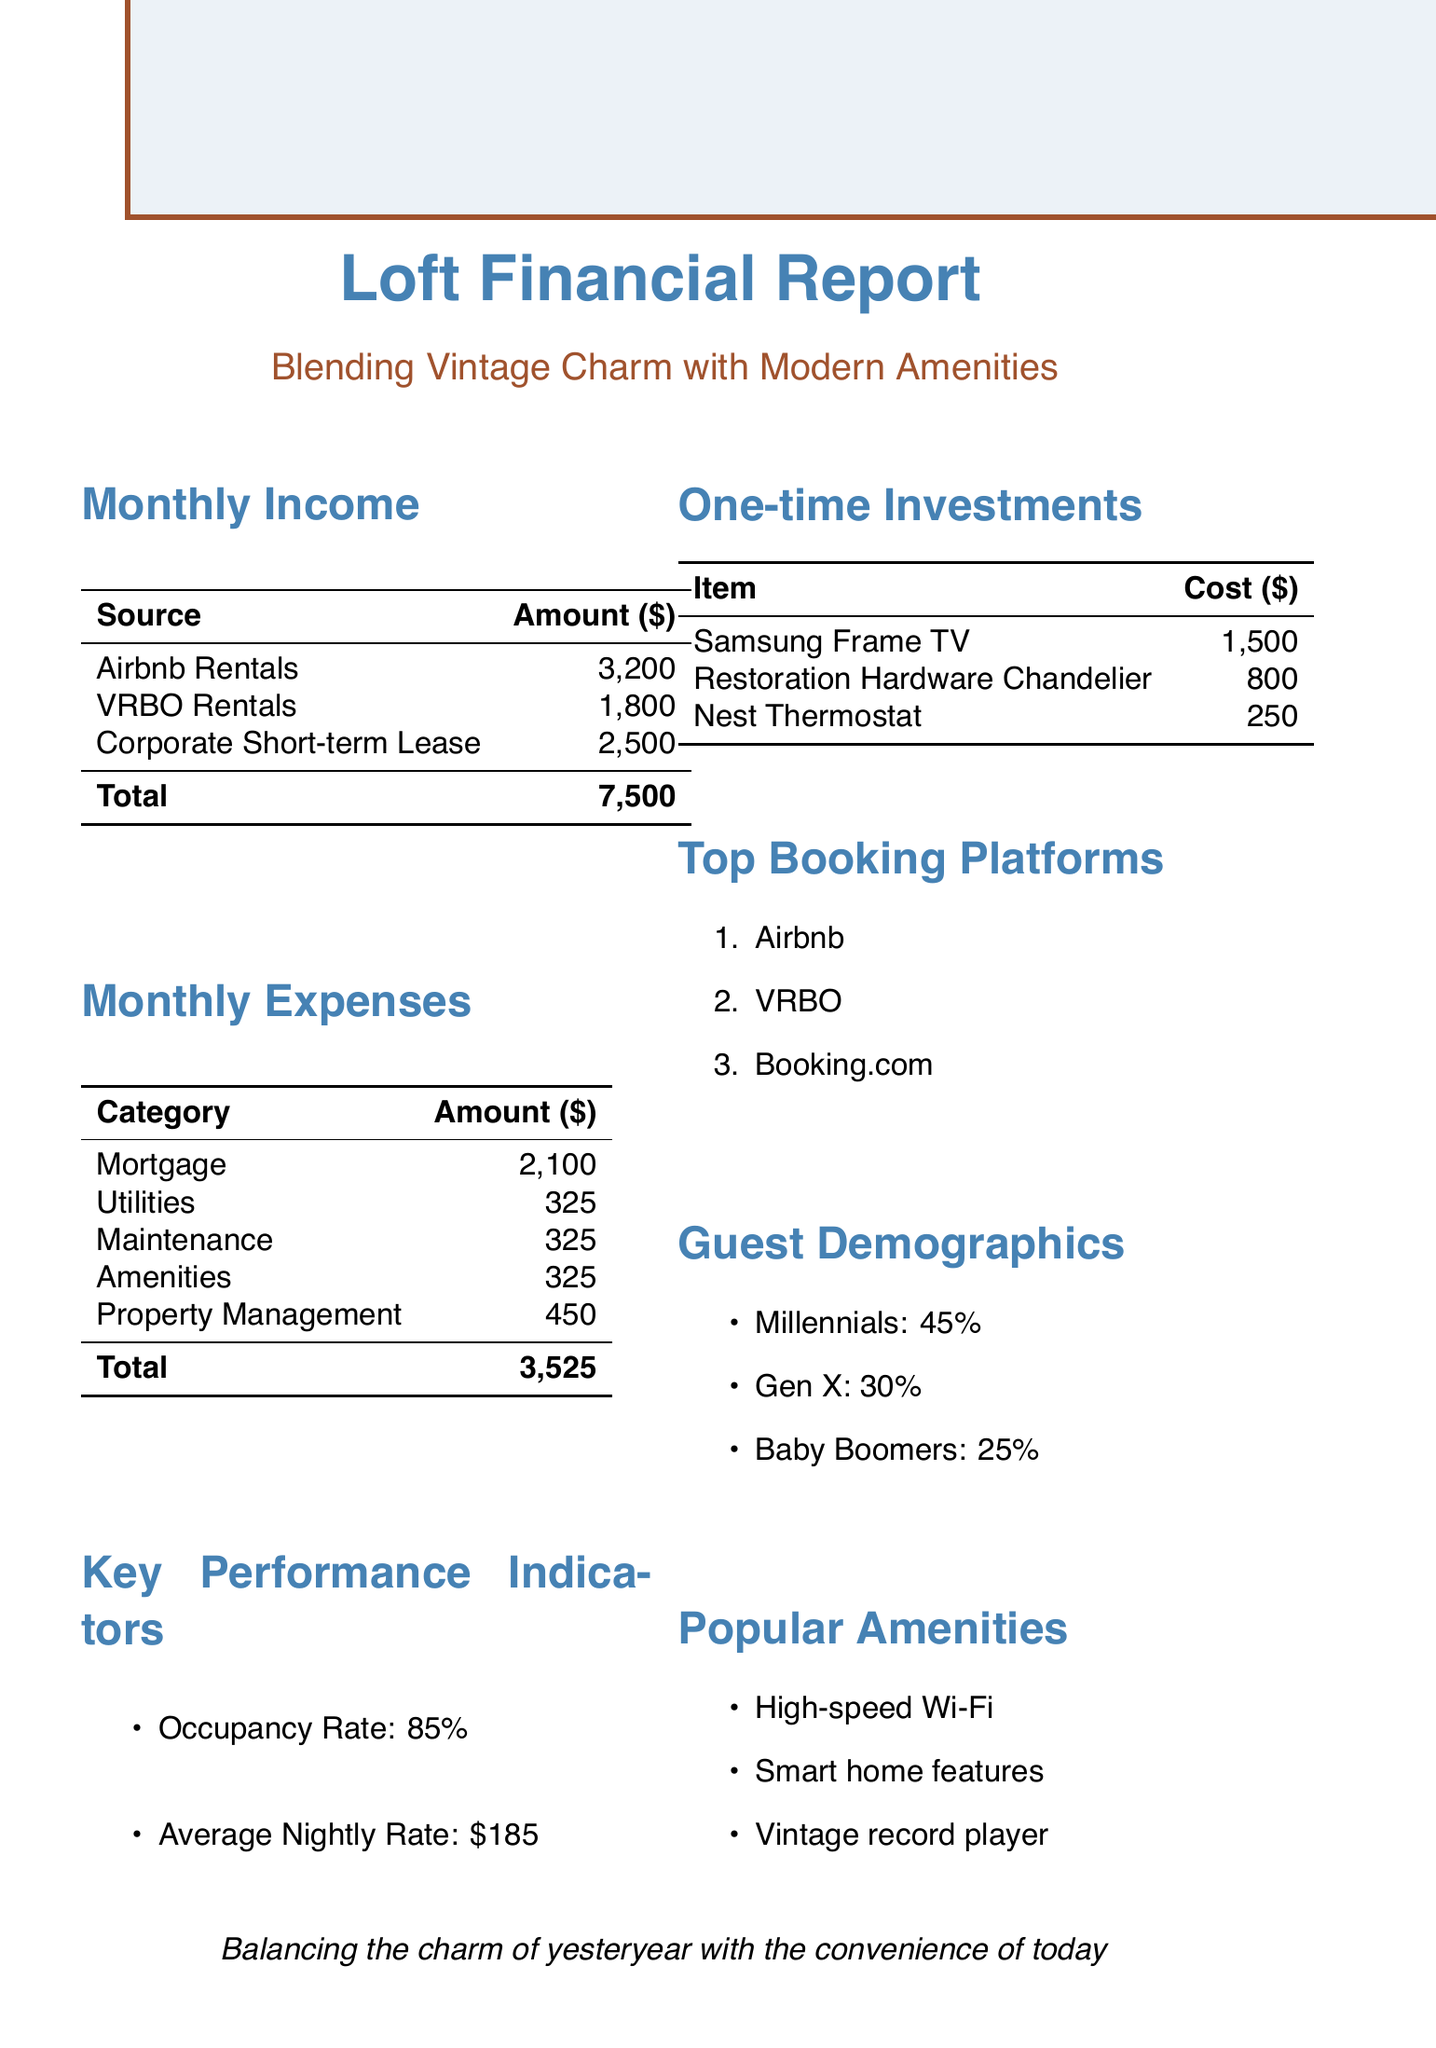what is the total monthly income from rentals? The total monthly income is the sum of Airbnb rentals, VRBO rentals, and corporate short-term lease, which is 3200 + 1800 + 2500 = 7500.
Answer: 7500 what is the mortgage expense per month? The mortgage expense is listed as a monthly expense in the document, which is $2100.
Answer: 2100 what is the total monthly expense? The total monthly expense is calculated by adding all expense categories: 2100 (mortgage) + 325 (utilities) + 325 (maintenance) + 325 (amenities) + 450 (property management) = 3525.
Answer: 3525 how much was spent on the Samsung Frame TV? The cost of the Samsung Frame TV is detailed under one-time expenses in the document, which is $1500.
Answer: 1500 what percentage of guests are millennials? The document specifies that millennials make up 45% of the guest demographics.
Answer: 45% what is the average nightly rate for rentals? The average nightly rate is stated as $185 in the key performance indicators section.
Answer: 185 what is the total cost for amenities maintenance per month? The total cost for amenities maintenance includes Netflix subscription, Spotify premium, and cleaning service, totaling 15 + 10 + 300 = 325.
Answer: 325 which platform generates the highest income? The platform generating the highest income is Airbnb, with $3200 in rentals.
Answer: Airbnb what is the occupancy rate? The occupancy rate is mentioned as 85% in the key performance indicators section of the report.
Answer: 85% 